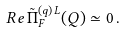<formula> <loc_0><loc_0><loc_500><loc_500>R e \, \tilde { \Pi } _ { F } ^ { ( q ) \, L } ( Q ) \simeq 0 \, .</formula> 